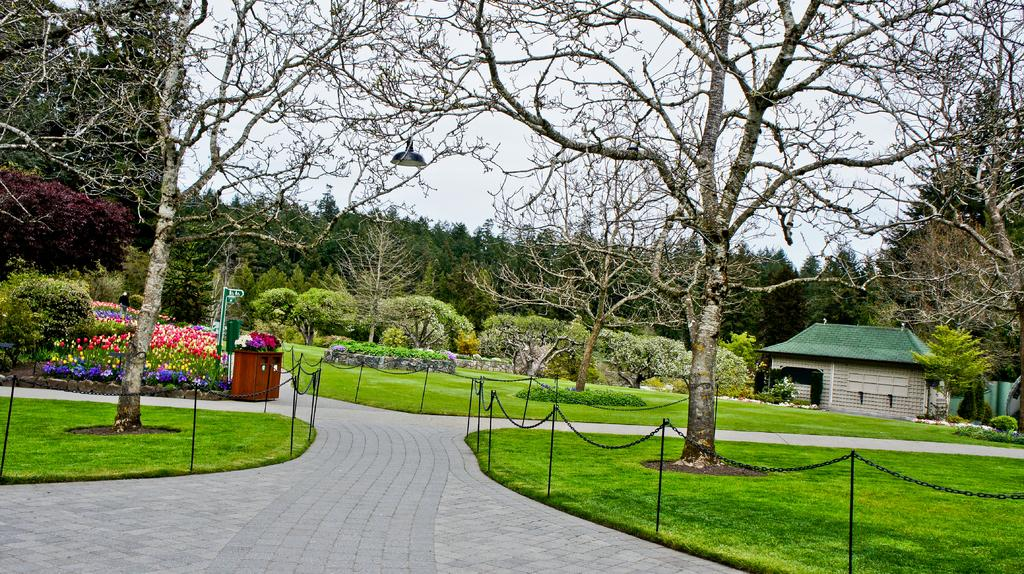What type of terrain is visible in the image? There is grassy land in the image. What kind of vegetation can be seen in the image? There are flower plants and trees in the image. What man-made structures are present in the image? There is a road, fencing, a cupboard, a sign board, a light, and a house in the image. What is the color of the sky in the image? The sky is white in color. How many babies are kicking a soccer ball in the image? There are no babies or soccer balls present in the image. What direction is the wind blowing in the image? There is no mention of wind in the image, so it cannot be determined from the provided facts. 